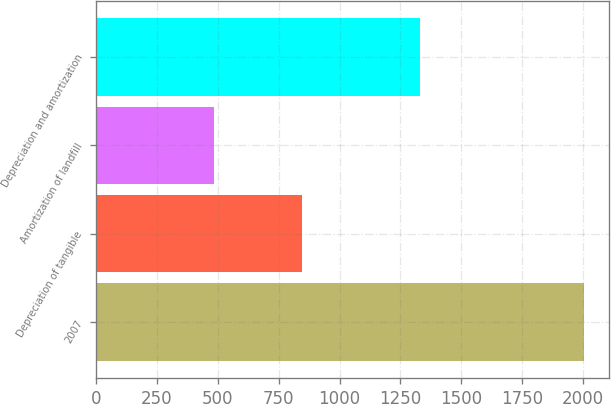Convert chart. <chart><loc_0><loc_0><loc_500><loc_500><bar_chart><fcel>2007<fcel>Depreciation of tangible<fcel>Amortization of landfill<fcel>Depreciation and amortization<nl><fcel>2005<fcel>847<fcel>483<fcel>1330<nl></chart> 